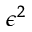<formula> <loc_0><loc_0><loc_500><loc_500>\epsilon ^ { 2 }</formula> 